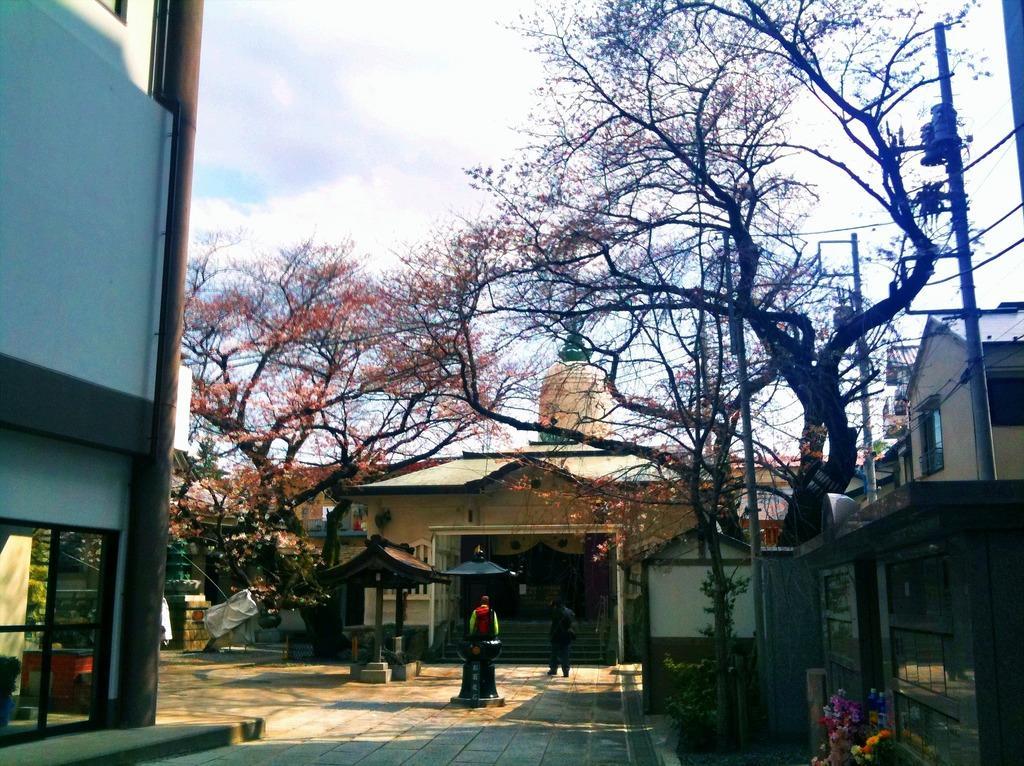How would you summarize this image in a sentence or two? The picture is taken outside a building. On the left there is a building. On the right there are poles, cables, trees, flowers and buildings. In the center of the picture there are trees, people and buildings. It is sunny. 